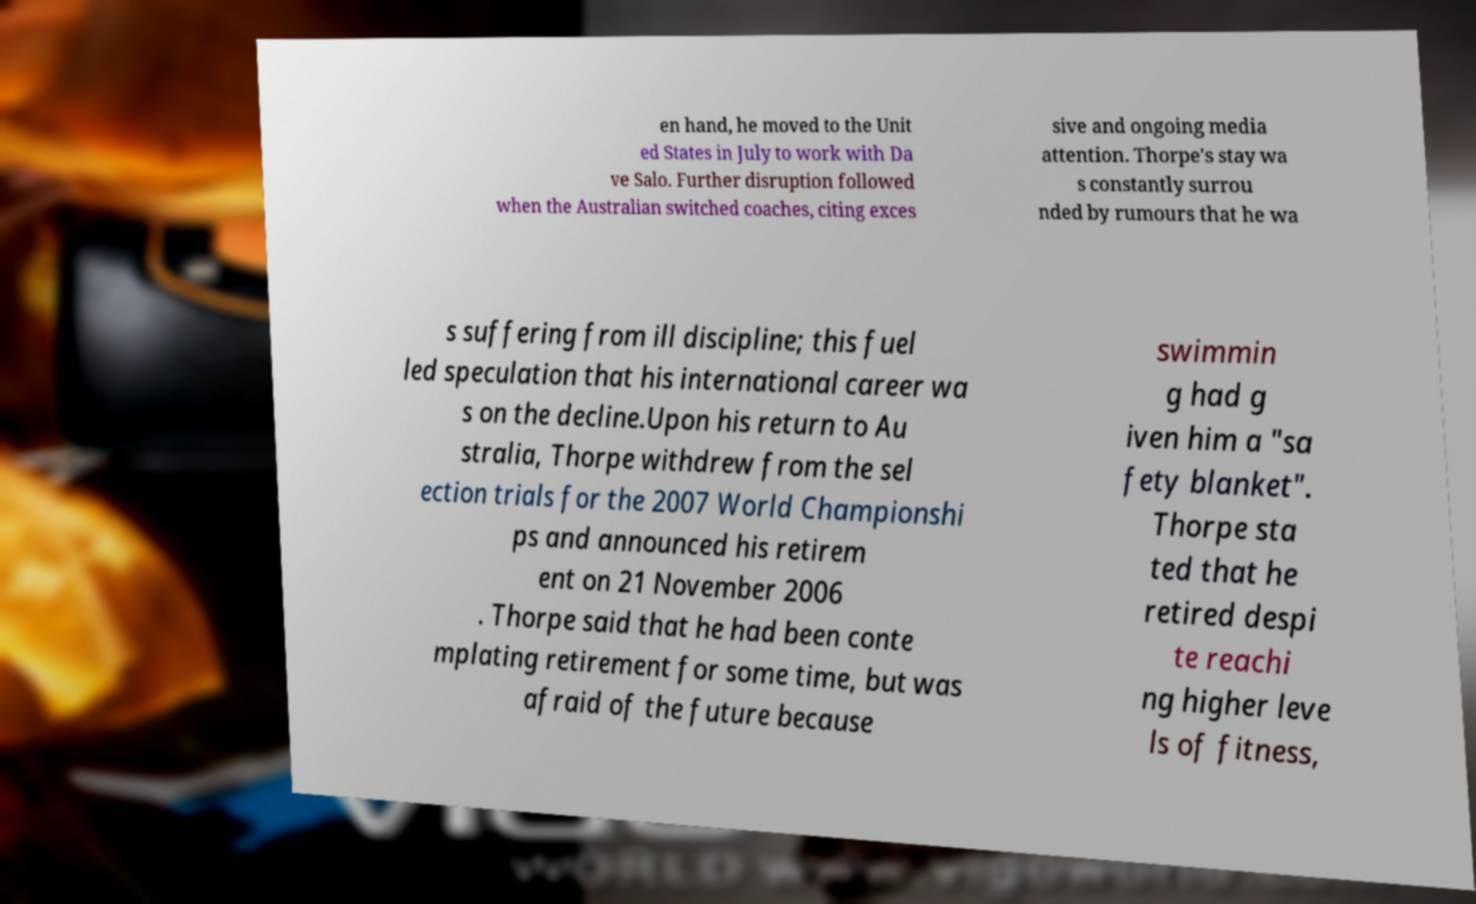For documentation purposes, I need the text within this image transcribed. Could you provide that? en hand, he moved to the Unit ed States in July to work with Da ve Salo. Further disruption followed when the Australian switched coaches, citing exces sive and ongoing media attention. Thorpe's stay wa s constantly surrou nded by rumours that he wa s suffering from ill discipline; this fuel led speculation that his international career wa s on the decline.Upon his return to Au stralia, Thorpe withdrew from the sel ection trials for the 2007 World Championshi ps and announced his retirem ent on 21 November 2006 . Thorpe said that he had been conte mplating retirement for some time, but was afraid of the future because swimmin g had g iven him a "sa fety blanket". Thorpe sta ted that he retired despi te reachi ng higher leve ls of fitness, 